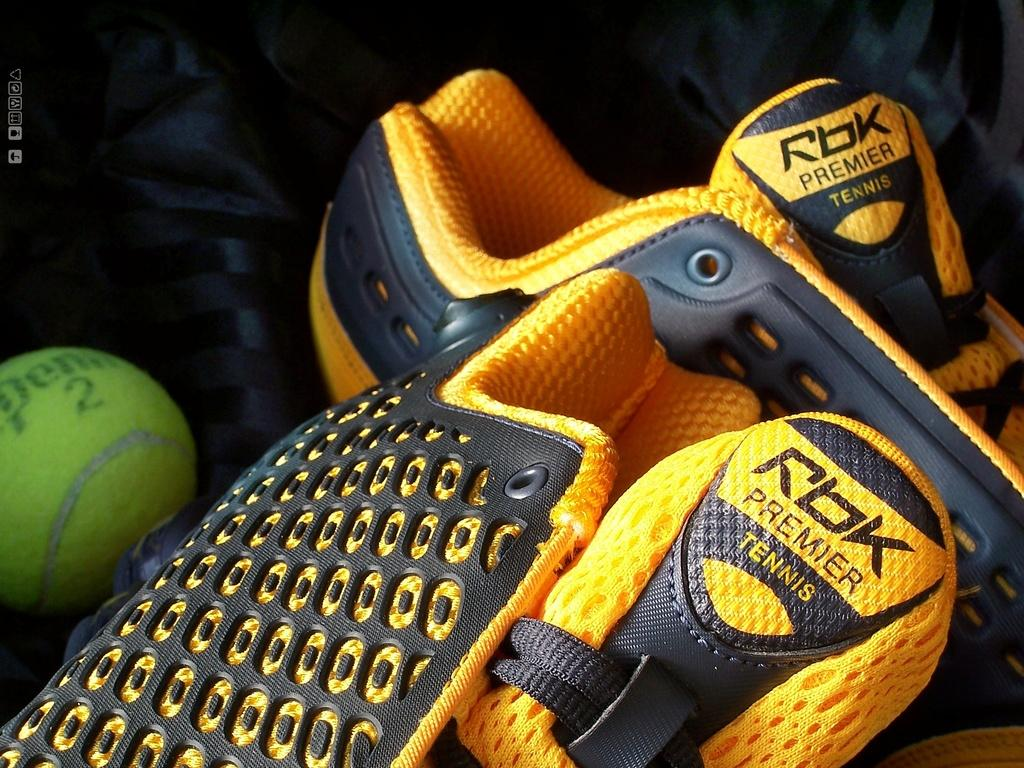What type of footwear is visible in the image? There are shoes in the image. What colors are the shoes? The shoes are yellow and black in color. What other object can be seen in the image? There is a ball in the image. What color is the ball? The ball is green in color. Can you tell me how much toothpaste is on the shoes in the image? There is no toothpaste present on the shoes in the image. Is there a bear visible in the image? There is no bear present in the image. 